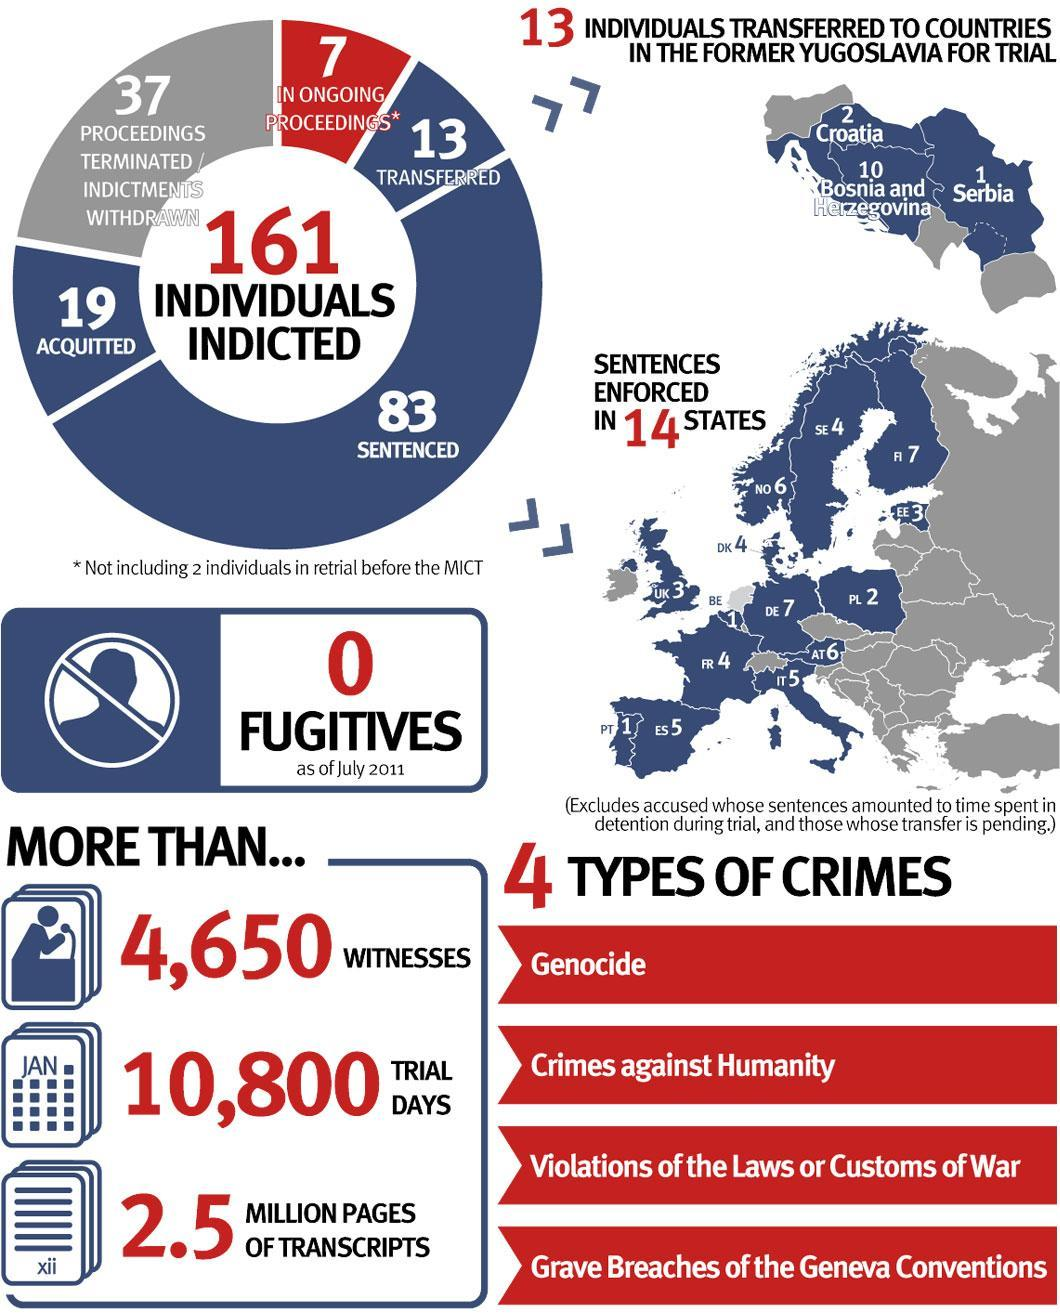To which countries in former Yugoslavia were 13 people transferred?
Answer the question with a short phrase. Croatia, Bosnia and Herzegovina, Serbia Which two crimes top the list in the infographic? Genocide, Crimes against Humanity How many people were transferred and sentenced? 96 